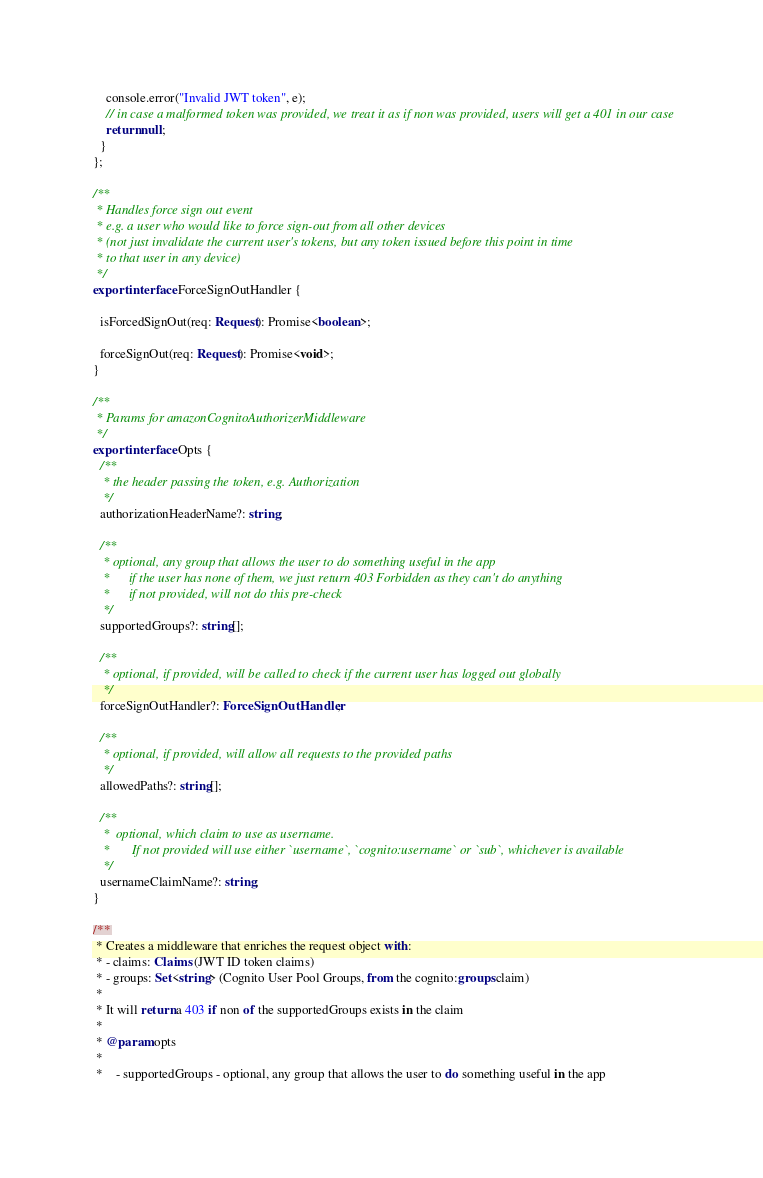Convert code to text. <code><loc_0><loc_0><loc_500><loc_500><_TypeScript_>    console.error("Invalid JWT token", e);
    // in case a malformed token was provided, we treat it as if non was provided, users will get a 401 in our case
    return null;
  }
};

/**
 * Handles force sign out event
 * e.g. a user who would like to force sign-out from all other devices
 * (not just invalidate the current user's tokens, but any token issued before this point in time
 * to that user in any device)
 */
export interface ForceSignOutHandler {

  isForcedSignOut(req: Request): Promise<boolean>;

  forceSignOut(req: Request): Promise<void>;
}

/**
 * Params for amazonCognitoAuthorizerMiddleware
 */
export interface Opts {
  /**
   * the header passing the token, e.g. Authorization
   */
  authorizationHeaderName?: string;

  /**
   * optional, any group that allows the user to do something useful in the app
   *      if the user has none of them, we just return 403 Forbidden as they can't do anything
   *      if not provided, will not do this pre-check
   */
  supportedGroups?: string[];

  /**
   * optional, if provided, will be called to check if the current user has logged out globally
   */
  forceSignOutHandler?: ForceSignOutHandler;

  /**
   * optional, if provided, will allow all requests to the provided paths
   */
  allowedPaths?: string[];

  /**
   *  optional, which claim to use as username.
   *       If not provided will use either `username`, `cognito:username` or `sub`, whichever is available
   */
  usernameClaimName?: string;
}

/**
 * Creates a middleware that enriches the request object with:
 * - claims: Claims (JWT ID token claims)
 * - groups: Set<string> (Cognito User Pool Groups, from the cognito:groups claim)
 *
 * It will return a 403 if non of the supportedGroups exists in the claim
 *
 * @param opts
 *
 *    - supportedGroups - optional, any group that allows the user to do something useful in the app</code> 